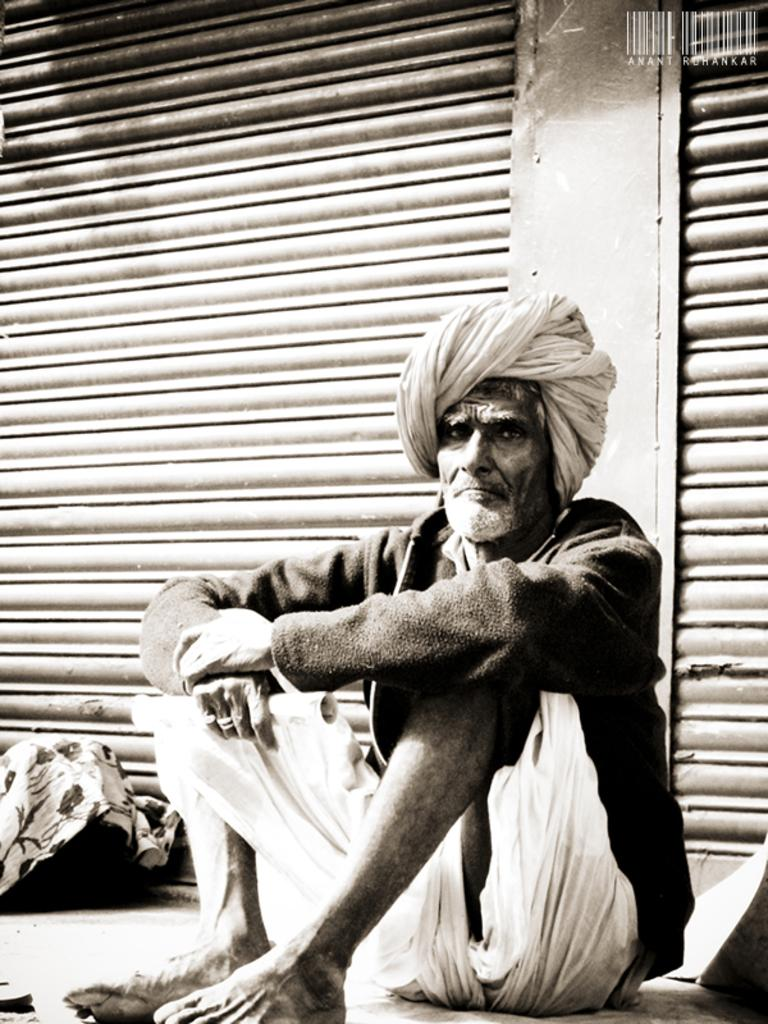What is the color scheme of the image? The image is black and white. What is the man in the image doing? The man is sitting on a footpath in the image. What can be seen in the background of the image? There is a shutter in the background of the image. Is the man sinking into quicksand in the image? No, there is no quicksand present in the image. What type of bean is growing near the man in the image? There are no beans present in the image. 